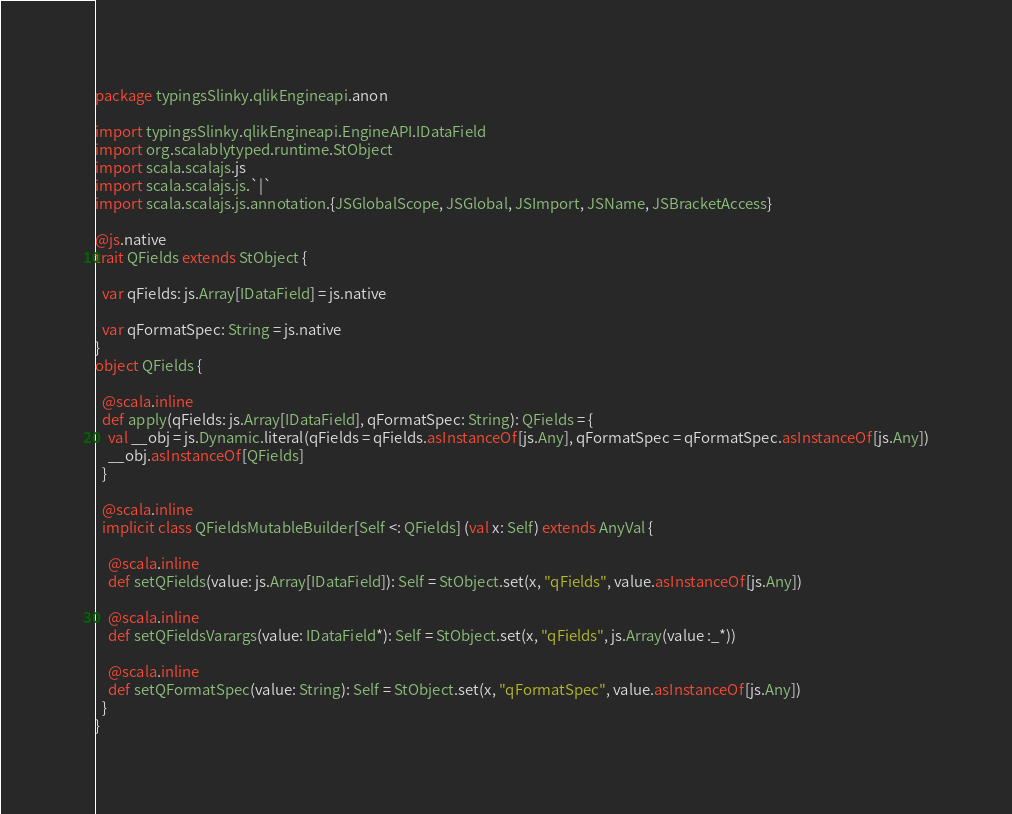Convert code to text. <code><loc_0><loc_0><loc_500><loc_500><_Scala_>package typingsSlinky.qlikEngineapi.anon

import typingsSlinky.qlikEngineapi.EngineAPI.IDataField
import org.scalablytyped.runtime.StObject
import scala.scalajs.js
import scala.scalajs.js.`|`
import scala.scalajs.js.annotation.{JSGlobalScope, JSGlobal, JSImport, JSName, JSBracketAccess}

@js.native
trait QFields extends StObject {
  
  var qFields: js.Array[IDataField] = js.native
  
  var qFormatSpec: String = js.native
}
object QFields {
  
  @scala.inline
  def apply(qFields: js.Array[IDataField], qFormatSpec: String): QFields = {
    val __obj = js.Dynamic.literal(qFields = qFields.asInstanceOf[js.Any], qFormatSpec = qFormatSpec.asInstanceOf[js.Any])
    __obj.asInstanceOf[QFields]
  }
  
  @scala.inline
  implicit class QFieldsMutableBuilder[Self <: QFields] (val x: Self) extends AnyVal {
    
    @scala.inline
    def setQFields(value: js.Array[IDataField]): Self = StObject.set(x, "qFields", value.asInstanceOf[js.Any])
    
    @scala.inline
    def setQFieldsVarargs(value: IDataField*): Self = StObject.set(x, "qFields", js.Array(value :_*))
    
    @scala.inline
    def setQFormatSpec(value: String): Self = StObject.set(x, "qFormatSpec", value.asInstanceOf[js.Any])
  }
}
</code> 